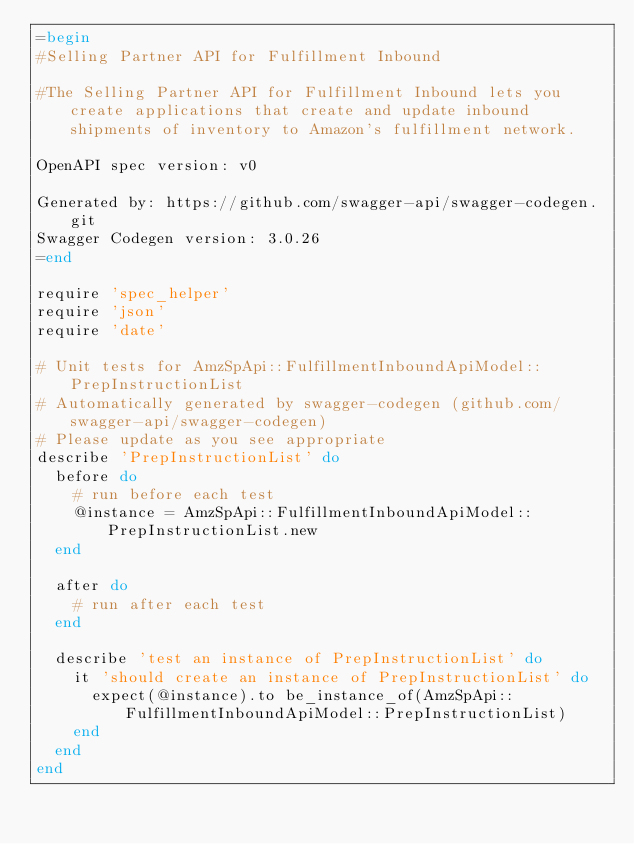<code> <loc_0><loc_0><loc_500><loc_500><_Ruby_>=begin
#Selling Partner API for Fulfillment Inbound

#The Selling Partner API for Fulfillment Inbound lets you create applications that create and update inbound shipments of inventory to Amazon's fulfillment network.

OpenAPI spec version: v0

Generated by: https://github.com/swagger-api/swagger-codegen.git
Swagger Codegen version: 3.0.26
=end

require 'spec_helper'
require 'json'
require 'date'

# Unit tests for AmzSpApi::FulfillmentInboundApiModel::PrepInstructionList
# Automatically generated by swagger-codegen (github.com/swagger-api/swagger-codegen)
# Please update as you see appropriate
describe 'PrepInstructionList' do
  before do
    # run before each test
    @instance = AmzSpApi::FulfillmentInboundApiModel::PrepInstructionList.new
  end

  after do
    # run after each test
  end

  describe 'test an instance of PrepInstructionList' do
    it 'should create an instance of PrepInstructionList' do
      expect(@instance).to be_instance_of(AmzSpApi::FulfillmentInboundApiModel::PrepInstructionList)
    end
  end
end
</code> 